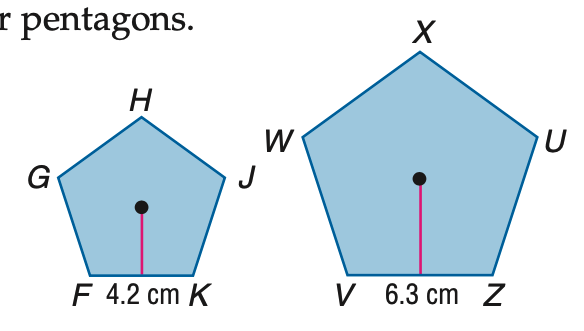Answer the mathemtical geometry problem and directly provide the correct option letter.
Question: Polygons F G H J K and V W X U Z are similar regular pentagons. Find the scale factor.
Choices: A: 1:2 B: 2:3 C: 3:2 D: 2:1 B 